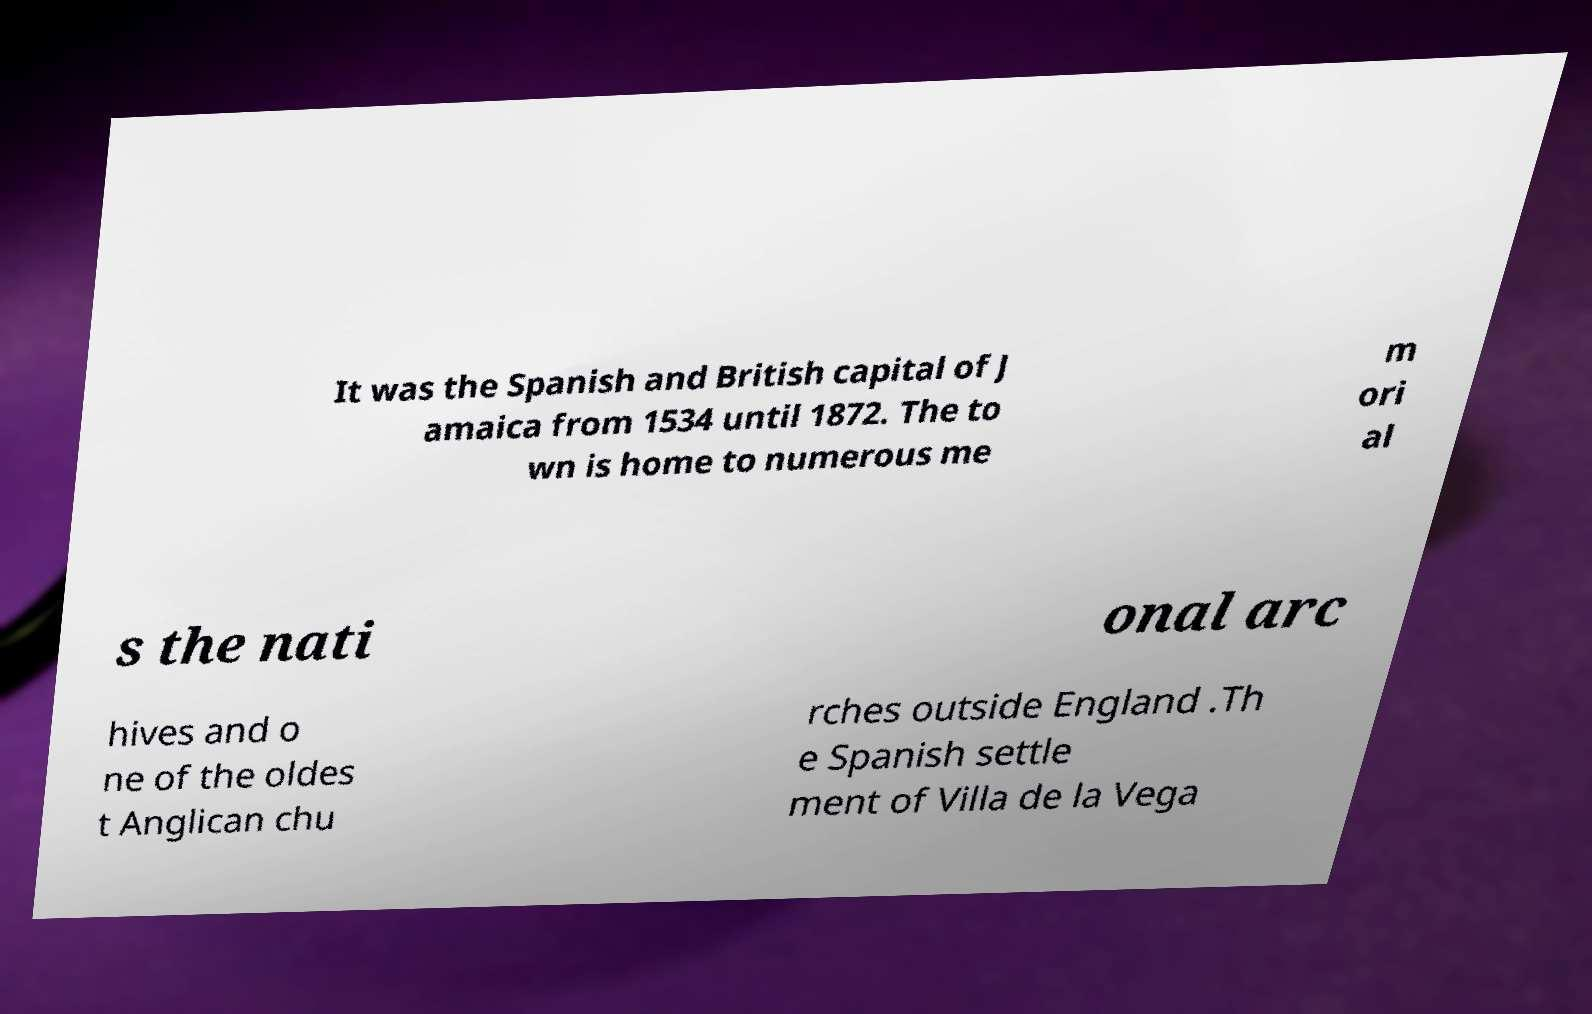Please identify and transcribe the text found in this image. It was the Spanish and British capital of J amaica from 1534 until 1872. The to wn is home to numerous me m ori al s the nati onal arc hives and o ne of the oldes t Anglican chu rches outside England .Th e Spanish settle ment of Villa de la Vega 